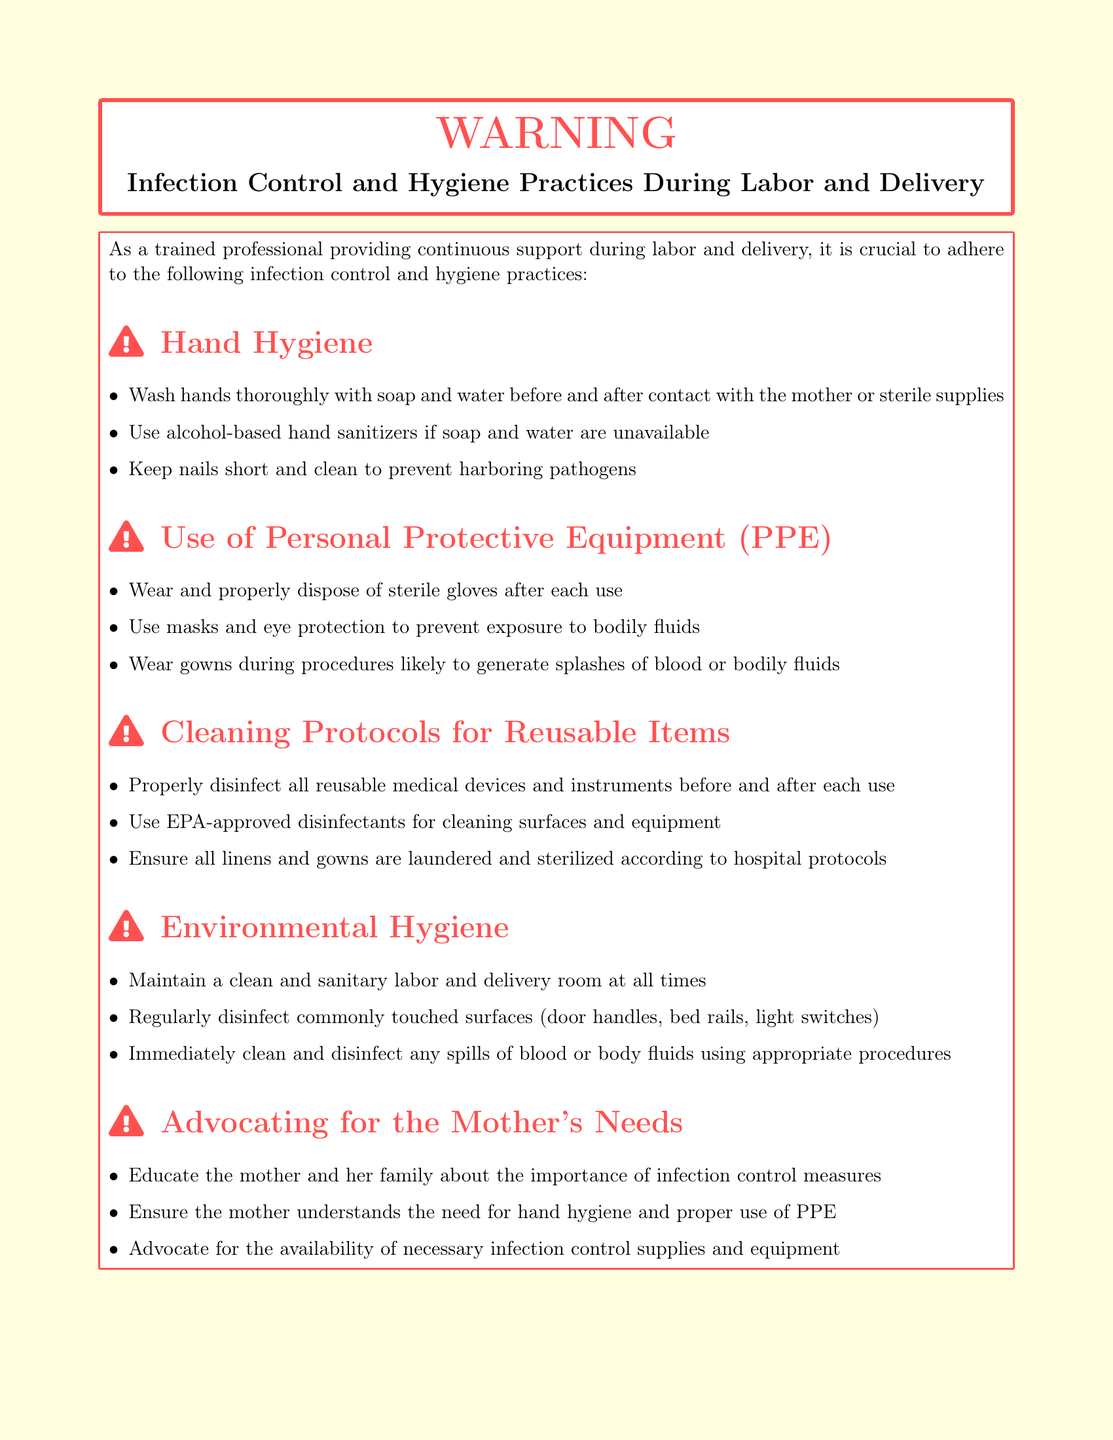What is the main topic of the warning? The main topic of the warning is the practices to reduce the risk of infections during labor and delivery.
Answer: Infection Control and Hygiene Practices During Labor and Delivery What should be done before and after contact with the mother? According to the document, hands should be washed thoroughly before and after contact with the mother or sterile supplies.
Answer: Wash hands thoroughly What personal protective equipment is mentioned? The document lists several types of personal protective equipment necessary during labor and delivery.
Answer: Sterile gloves, masks, eye protection, gowns What cleaning agents are recommended for disinfecting surfaces? The warning specifies the type of disinfectants to use for cleaning surfaces and equipment.
Answer: EPA-approved disinfectants How often should commonly touched surfaces be disinfected? The document emphasizes the importance of maintaining cleanliness in the labor and delivery room, implying a frequency for cleaning.
Answer: Regularly disinfect What should be done if there is a spill of blood or bodily fluids? The recommended action for spills is explicitly mentioned in the document.
Answer: Immediately clean and disinfect What is one role of the trained professional regarding the mother? The document highlights an advocacy role for the trained professional during labor and delivery.
Answer: Advocate for the mother's needs How should linens and gowns be treated? The document provides specific instructions for the treatment of linens and gowns.
Answer: Laundered and sterilized 